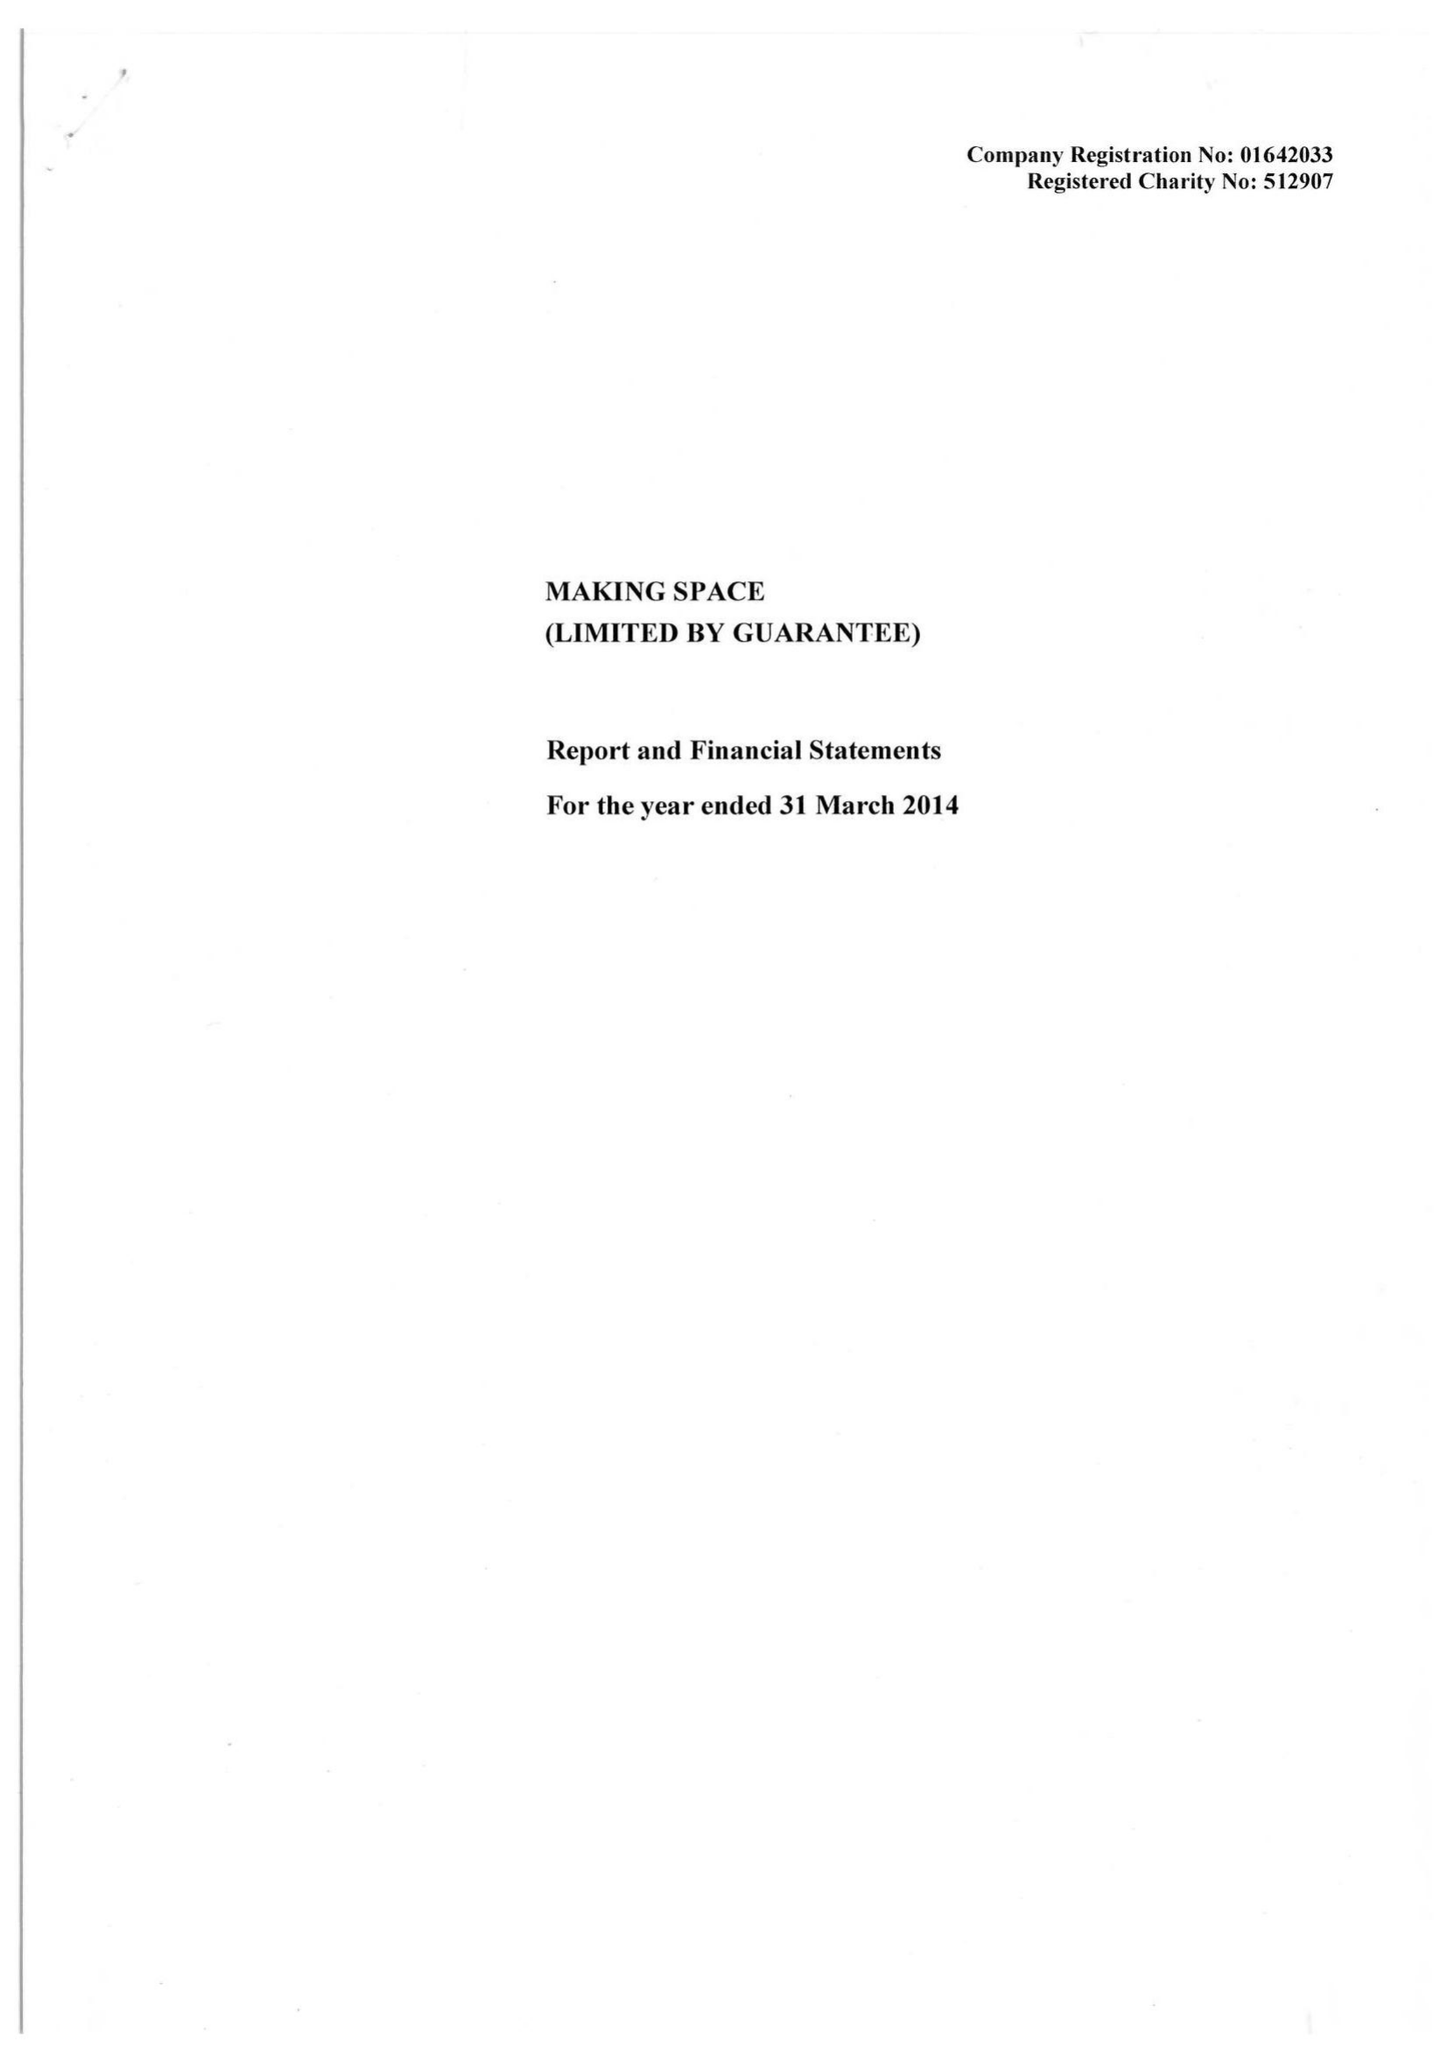What is the value for the income_annually_in_british_pounds?
Answer the question using a single word or phrase. 21295266.00 